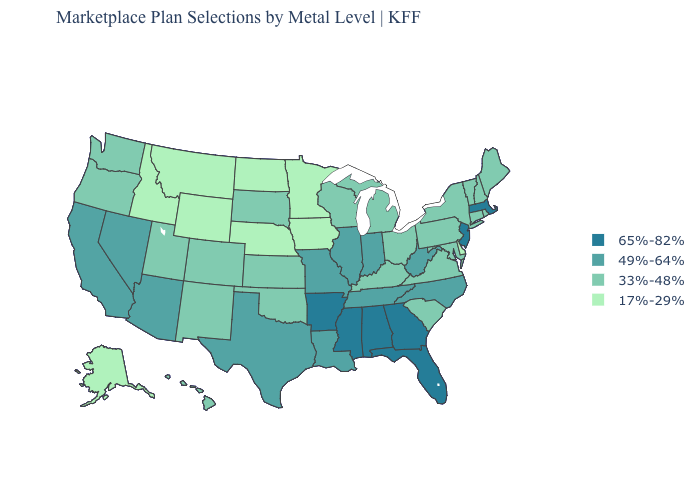Is the legend a continuous bar?
Concise answer only. No. What is the highest value in states that border New York?
Concise answer only. 65%-82%. Which states have the lowest value in the USA?
Concise answer only. Alaska, Delaware, Idaho, Iowa, Minnesota, Montana, Nebraska, North Dakota, Wyoming. Which states have the lowest value in the South?
Keep it brief. Delaware. Does Kansas have the highest value in the USA?
Short answer required. No. What is the value of Utah?
Give a very brief answer. 33%-48%. What is the value of Alaska?
Give a very brief answer. 17%-29%. Name the states that have a value in the range 49%-64%?
Keep it brief. Arizona, California, Illinois, Indiana, Louisiana, Missouri, Nevada, North Carolina, Tennessee, Texas, West Virginia. What is the value of Virginia?
Answer briefly. 33%-48%. Which states have the highest value in the USA?
Write a very short answer. Alabama, Arkansas, Florida, Georgia, Massachusetts, Mississippi, New Jersey. What is the lowest value in the MidWest?
Give a very brief answer. 17%-29%. Does Wyoming have the lowest value in the USA?
Quick response, please. Yes. Does the map have missing data?
Quick response, please. No. Among the states that border Iowa , does Nebraska have the lowest value?
Write a very short answer. Yes. Name the states that have a value in the range 33%-48%?
Be succinct. Colorado, Connecticut, Hawaii, Kansas, Kentucky, Maine, Maryland, Michigan, New Hampshire, New Mexico, New York, Ohio, Oklahoma, Oregon, Pennsylvania, Rhode Island, South Carolina, South Dakota, Utah, Vermont, Virginia, Washington, Wisconsin. 